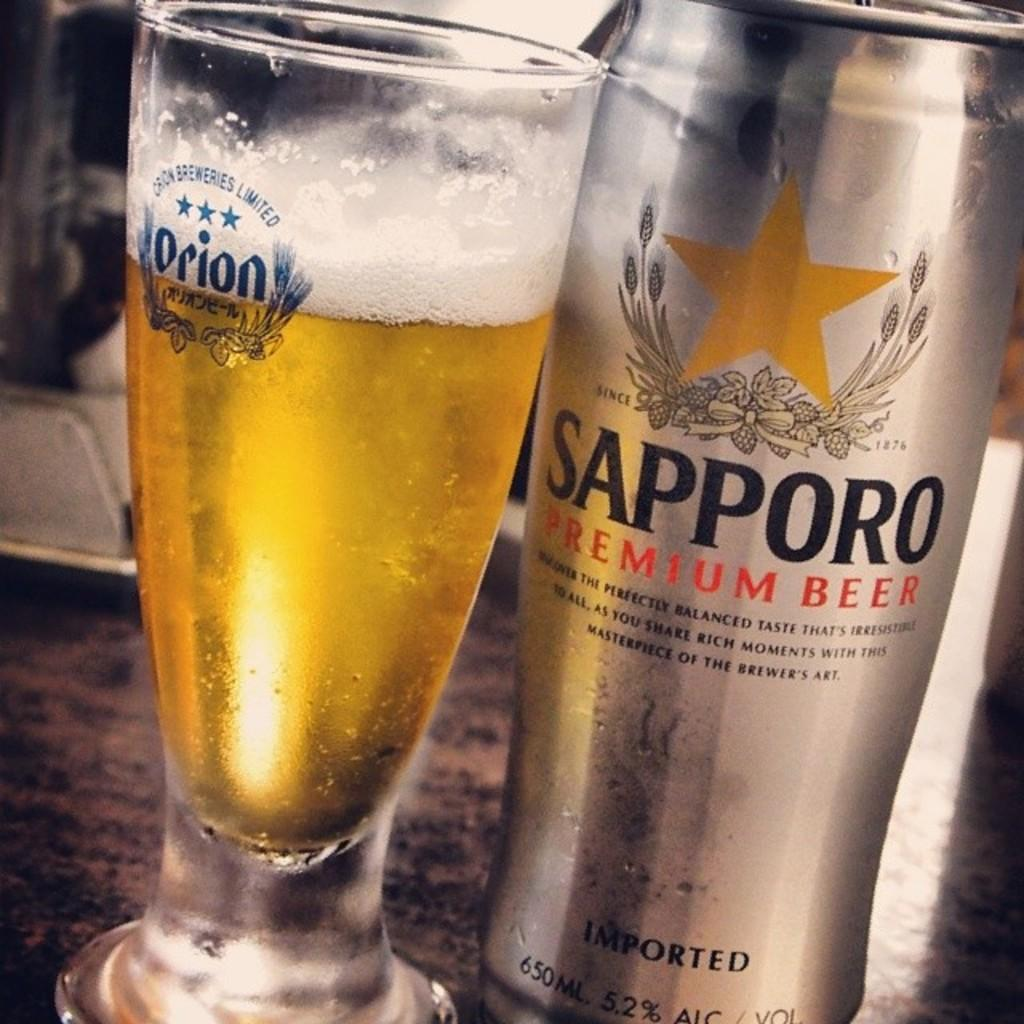What piece of furniture is present in the image? There is a table in the image. What is placed on the table? There is a glass and a bottle on the table. What type of mist can be seen surrounding the glass in the image? There is no mist present in the image; it is a clear image with a glass and a bottle on a table. 